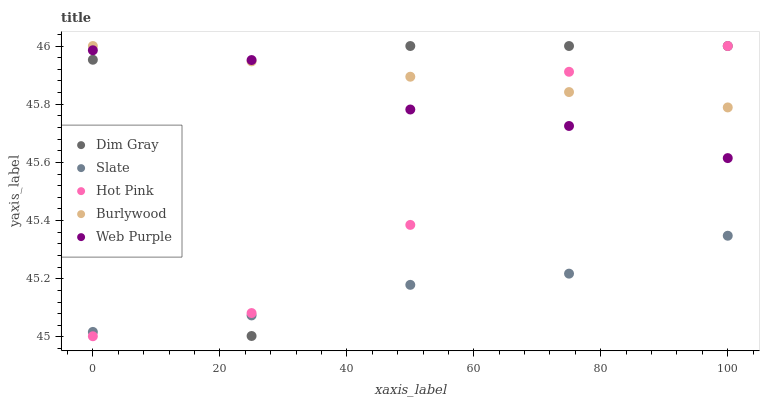Does Slate have the minimum area under the curve?
Answer yes or no. Yes. Does Burlywood have the maximum area under the curve?
Answer yes or no. Yes. Does Dim Gray have the minimum area under the curve?
Answer yes or no. No. Does Dim Gray have the maximum area under the curve?
Answer yes or no. No. Is Burlywood the smoothest?
Answer yes or no. Yes. Is Dim Gray the roughest?
Answer yes or no. Yes. Is Slate the smoothest?
Answer yes or no. No. Is Slate the roughest?
Answer yes or no. No. Does Hot Pink have the lowest value?
Answer yes or no. Yes. Does Slate have the lowest value?
Answer yes or no. No. Does Hot Pink have the highest value?
Answer yes or no. Yes. Does Slate have the highest value?
Answer yes or no. No. Is Slate less than Burlywood?
Answer yes or no. Yes. Is Web Purple greater than Slate?
Answer yes or no. Yes. Does Hot Pink intersect Web Purple?
Answer yes or no. Yes. Is Hot Pink less than Web Purple?
Answer yes or no. No. Is Hot Pink greater than Web Purple?
Answer yes or no. No. Does Slate intersect Burlywood?
Answer yes or no. No. 